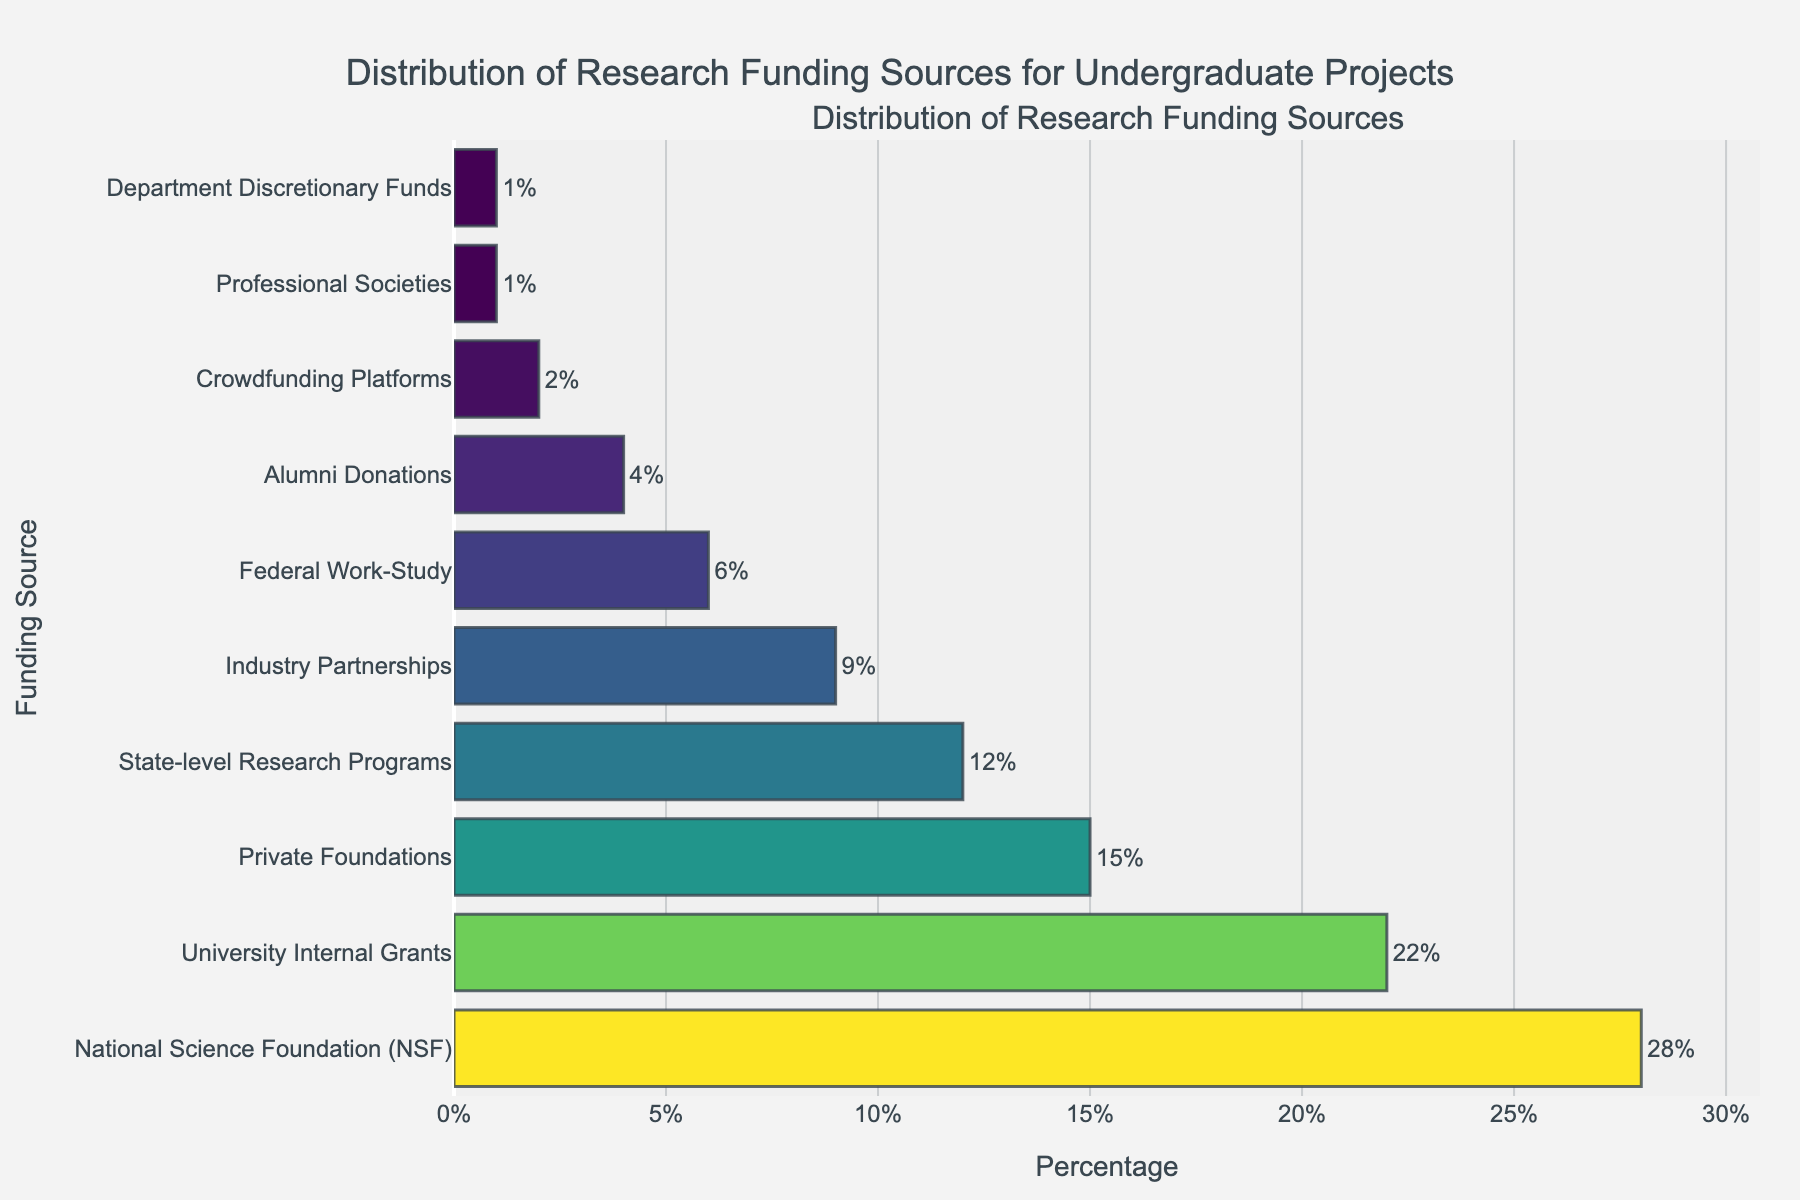What is the most common source of research funding for undergraduate projects? The bar representing the "National Science Foundation (NSF)" is the longest, which indicates that it is the most common source. It is labeled with 28%.
Answer: National Science Foundation (NSF) What is the combined percentage of funding from private foundations and industry partnerships? The percentages for "Private Foundations" and "Industry Partnerships" are 15% and 9%, respectively. Adding them together gives 15% + 9% = 24%.
Answer: 24% Which funding source contributes more: State-level Research Programs or University Internal Grants? The bar for "University Internal Grants" is longer than that for "State-level Research Programs". University Internal Grants are at 22%, and State-level Research Programs are at 12%. Therefore, University Internal Grants contribute more.
Answer: University Internal Grants Are there more funding sources contributing below 10% or above 10%? Count the number of funding sources with percentages below 10% and those above 10%. There are seven funding sources below 10% (Industry Partnerships, Federal Work-Study, Alumni Donations, Crowdfunding Platforms, Professional Societies, Department Discretionary Funds) and four funding sources above 10% (National Science Foundation, University Internal Grants, Private Foundations, State-level Research Programs). Therefore, there are more below 10%.
Answer: Below 10% What is the smallest percentage contribution among all funding sources? The smallest bar represents "Professional Societies" and "Department Discretionary Funds," each with a contribution of 1%.
Answer: 1% How much larger is the contribution from National Science Foundation compared to Federal Work-Study? The contribution from the National Science Foundation is 28%, while the contribution from Federal Work-Study is 6%. The difference is 28% - 6% = 22%.
Answer: 22% Which source has the third-highest percentage of funding, and what is that percentage? The third-longest bar identifies the source, "Private Foundations," which has a percentage of 15%.
Answer: Private Foundations, 15% How does the percentage from Alumni Donations compare to the percentage from Crowdfunding Platforms? The bar for Alumni Donations (4%) is longer than that for Crowdfunding Platforms (2%), so Alumni Donations has a higher percentage.
Answer: Alumni Donations If you were to combine the contributions from Professional Societies and Department Discretionary Funds, what would be the total percentage? Both contribute 1% each, so their combined total is 1% + 1% = 2%.
Answer: 2% What is the average percentage of funding for the top three sources? The top three sources are NSF (28%), University Internal Grants (22%), and Private Foundations (15%). Their total is 28 + 22 + 15 = 65. Dividing by 3 gives an average of 65/3 ≈ 21.67%.
Answer: 21.67% 